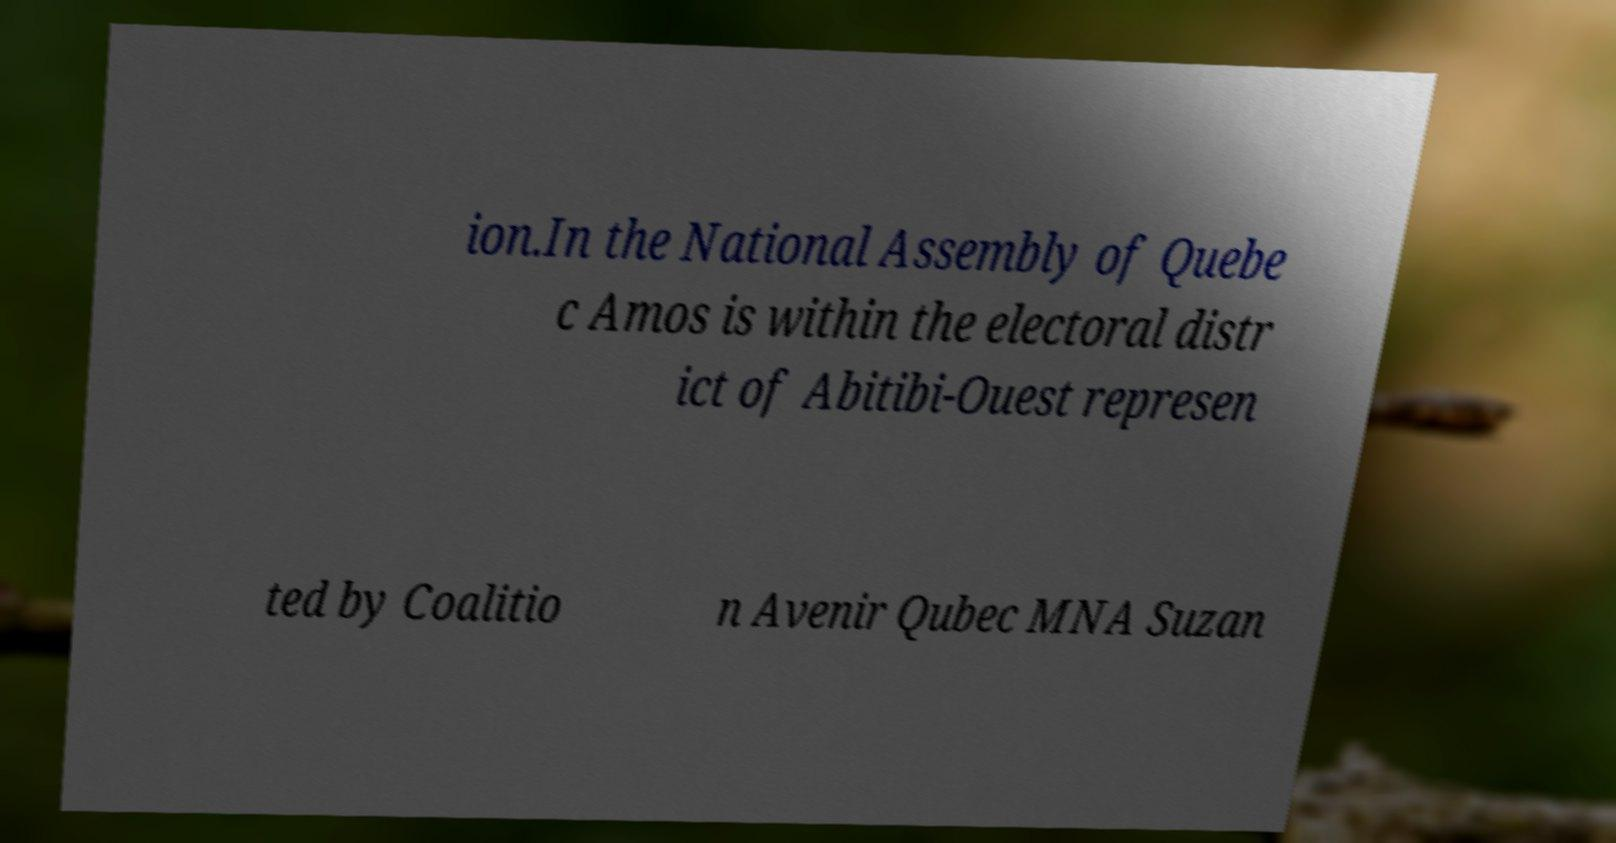What messages or text are displayed in this image? I need them in a readable, typed format. ion.In the National Assembly of Quebe c Amos is within the electoral distr ict of Abitibi-Ouest represen ted by Coalitio n Avenir Qubec MNA Suzan 